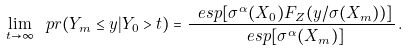<formula> <loc_0><loc_0><loc_500><loc_500>\lim _ { t \to \infty } \ p r ( Y _ { m } \leq y | Y _ { 0 } > t ) = \frac { \ e s p [ \sigma ^ { \alpha } ( X _ { 0 } ) F _ { Z } ( y / \sigma ( X _ { m } ) ) ] } { \ e s p [ \sigma ^ { \alpha } ( X _ { m } ) ] } \, .</formula> 